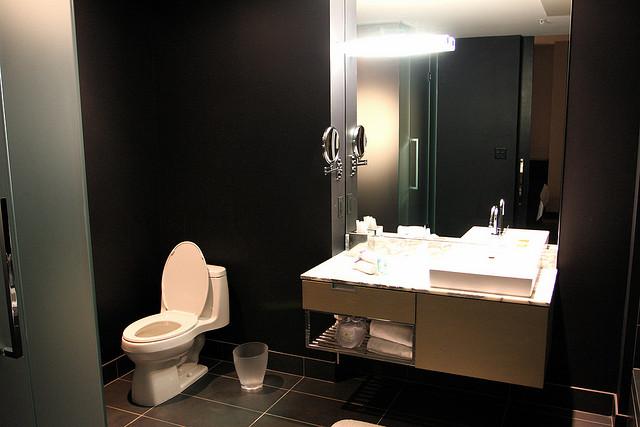Are the walls dark?
Short answer required. Yes. Is there a mirror in this room?
Answer briefly. Yes. What room is this?
Give a very brief answer. Bathroom. 